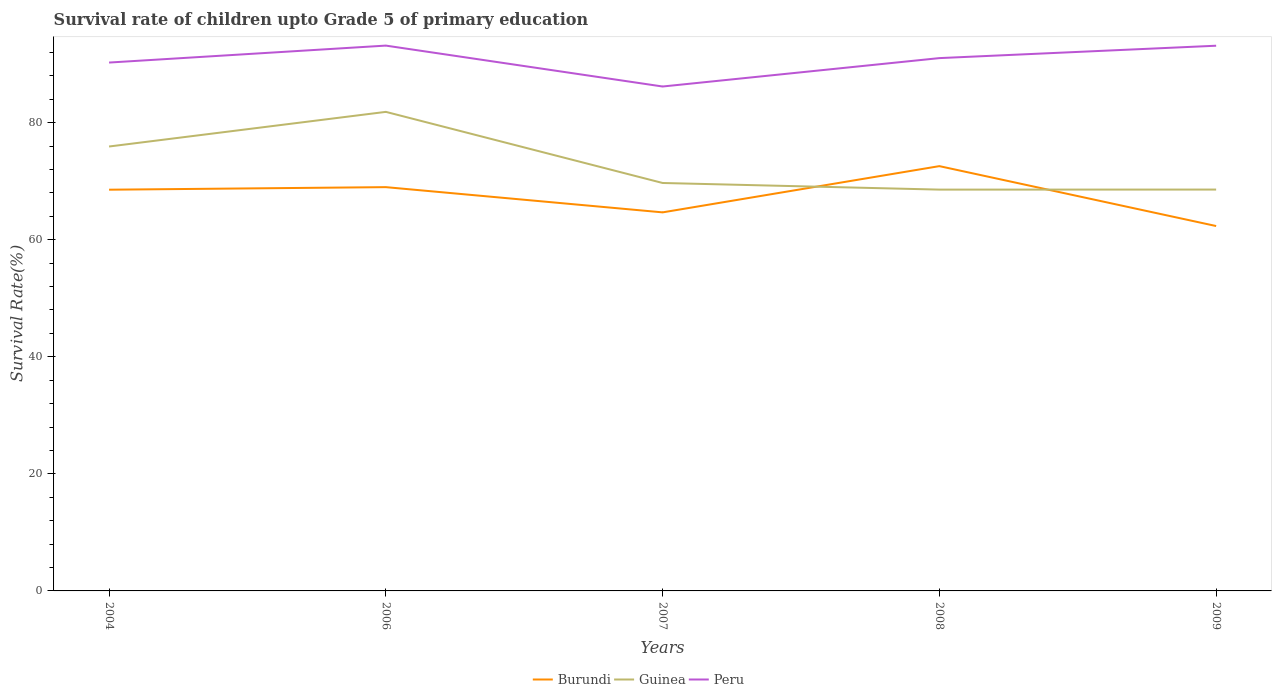Does the line corresponding to Peru intersect with the line corresponding to Burundi?
Your answer should be compact. No. Is the number of lines equal to the number of legend labels?
Your response must be concise. Yes. Across all years, what is the maximum survival rate of children in Guinea?
Your answer should be very brief. 68.57. What is the total survival rate of children in Peru in the graph?
Make the answer very short. -2.88. What is the difference between the highest and the second highest survival rate of children in Burundi?
Your answer should be very brief. 10.24. How many lines are there?
Give a very brief answer. 3. How many legend labels are there?
Give a very brief answer. 3. How are the legend labels stacked?
Make the answer very short. Horizontal. What is the title of the graph?
Provide a short and direct response. Survival rate of children upto Grade 5 of primary education. What is the label or title of the X-axis?
Make the answer very short. Years. What is the label or title of the Y-axis?
Your answer should be compact. Survival Rate(%). What is the Survival Rate(%) in Burundi in 2004?
Keep it short and to the point. 68.55. What is the Survival Rate(%) of Guinea in 2004?
Ensure brevity in your answer.  75.93. What is the Survival Rate(%) of Peru in 2004?
Your response must be concise. 90.28. What is the Survival Rate(%) of Burundi in 2006?
Provide a short and direct response. 68.99. What is the Survival Rate(%) in Guinea in 2006?
Provide a succinct answer. 81.85. What is the Survival Rate(%) in Peru in 2006?
Make the answer very short. 93.18. What is the Survival Rate(%) of Burundi in 2007?
Provide a short and direct response. 64.68. What is the Survival Rate(%) in Guinea in 2007?
Your answer should be compact. 69.7. What is the Survival Rate(%) in Peru in 2007?
Offer a very short reply. 86.19. What is the Survival Rate(%) of Burundi in 2008?
Your response must be concise. 72.58. What is the Survival Rate(%) of Guinea in 2008?
Give a very brief answer. 68.57. What is the Survival Rate(%) of Peru in 2008?
Keep it short and to the point. 91.04. What is the Survival Rate(%) of Burundi in 2009?
Your response must be concise. 62.35. What is the Survival Rate(%) of Guinea in 2009?
Provide a succinct answer. 68.58. What is the Survival Rate(%) in Peru in 2009?
Your response must be concise. 93.16. Across all years, what is the maximum Survival Rate(%) in Burundi?
Provide a succinct answer. 72.58. Across all years, what is the maximum Survival Rate(%) in Guinea?
Make the answer very short. 81.85. Across all years, what is the maximum Survival Rate(%) of Peru?
Ensure brevity in your answer.  93.18. Across all years, what is the minimum Survival Rate(%) in Burundi?
Make the answer very short. 62.35. Across all years, what is the minimum Survival Rate(%) of Guinea?
Your answer should be very brief. 68.57. Across all years, what is the minimum Survival Rate(%) of Peru?
Provide a succinct answer. 86.19. What is the total Survival Rate(%) of Burundi in the graph?
Provide a succinct answer. 337.16. What is the total Survival Rate(%) in Guinea in the graph?
Keep it short and to the point. 364.64. What is the total Survival Rate(%) of Peru in the graph?
Provide a succinct answer. 453.84. What is the difference between the Survival Rate(%) in Burundi in 2004 and that in 2006?
Make the answer very short. -0.44. What is the difference between the Survival Rate(%) in Guinea in 2004 and that in 2006?
Offer a very short reply. -5.92. What is the difference between the Survival Rate(%) of Peru in 2004 and that in 2006?
Ensure brevity in your answer.  -2.9. What is the difference between the Survival Rate(%) of Burundi in 2004 and that in 2007?
Your answer should be very brief. 3.87. What is the difference between the Survival Rate(%) in Guinea in 2004 and that in 2007?
Provide a short and direct response. 6.23. What is the difference between the Survival Rate(%) in Peru in 2004 and that in 2007?
Offer a terse response. 4.09. What is the difference between the Survival Rate(%) of Burundi in 2004 and that in 2008?
Provide a succinct answer. -4.03. What is the difference between the Survival Rate(%) of Guinea in 2004 and that in 2008?
Provide a short and direct response. 7.36. What is the difference between the Survival Rate(%) in Peru in 2004 and that in 2008?
Your answer should be compact. -0.76. What is the difference between the Survival Rate(%) of Burundi in 2004 and that in 2009?
Your response must be concise. 6.21. What is the difference between the Survival Rate(%) in Guinea in 2004 and that in 2009?
Keep it short and to the point. 7.36. What is the difference between the Survival Rate(%) in Peru in 2004 and that in 2009?
Provide a short and direct response. -2.88. What is the difference between the Survival Rate(%) of Burundi in 2006 and that in 2007?
Provide a short and direct response. 4.31. What is the difference between the Survival Rate(%) in Guinea in 2006 and that in 2007?
Your answer should be very brief. 12.15. What is the difference between the Survival Rate(%) of Peru in 2006 and that in 2007?
Give a very brief answer. 6.99. What is the difference between the Survival Rate(%) of Burundi in 2006 and that in 2008?
Provide a short and direct response. -3.59. What is the difference between the Survival Rate(%) in Guinea in 2006 and that in 2008?
Provide a succinct answer. 13.28. What is the difference between the Survival Rate(%) in Peru in 2006 and that in 2008?
Your answer should be very brief. 2.14. What is the difference between the Survival Rate(%) of Burundi in 2006 and that in 2009?
Provide a succinct answer. 6.65. What is the difference between the Survival Rate(%) of Guinea in 2006 and that in 2009?
Give a very brief answer. 13.28. What is the difference between the Survival Rate(%) of Peru in 2006 and that in 2009?
Offer a very short reply. 0.02. What is the difference between the Survival Rate(%) in Burundi in 2007 and that in 2008?
Offer a very short reply. -7.9. What is the difference between the Survival Rate(%) in Guinea in 2007 and that in 2008?
Offer a very short reply. 1.13. What is the difference between the Survival Rate(%) of Peru in 2007 and that in 2008?
Provide a succinct answer. -4.85. What is the difference between the Survival Rate(%) in Burundi in 2007 and that in 2009?
Offer a very short reply. 2.34. What is the difference between the Survival Rate(%) of Guinea in 2007 and that in 2009?
Offer a very short reply. 1.12. What is the difference between the Survival Rate(%) of Peru in 2007 and that in 2009?
Offer a very short reply. -6.97. What is the difference between the Survival Rate(%) of Burundi in 2008 and that in 2009?
Offer a very short reply. 10.24. What is the difference between the Survival Rate(%) in Guinea in 2008 and that in 2009?
Your response must be concise. -0.01. What is the difference between the Survival Rate(%) in Peru in 2008 and that in 2009?
Your response must be concise. -2.12. What is the difference between the Survival Rate(%) of Burundi in 2004 and the Survival Rate(%) of Guinea in 2006?
Your answer should be compact. -13.3. What is the difference between the Survival Rate(%) of Burundi in 2004 and the Survival Rate(%) of Peru in 2006?
Ensure brevity in your answer.  -24.62. What is the difference between the Survival Rate(%) of Guinea in 2004 and the Survival Rate(%) of Peru in 2006?
Provide a succinct answer. -17.24. What is the difference between the Survival Rate(%) in Burundi in 2004 and the Survival Rate(%) in Guinea in 2007?
Your answer should be very brief. -1.15. What is the difference between the Survival Rate(%) of Burundi in 2004 and the Survival Rate(%) of Peru in 2007?
Provide a succinct answer. -17.63. What is the difference between the Survival Rate(%) in Guinea in 2004 and the Survival Rate(%) in Peru in 2007?
Give a very brief answer. -10.25. What is the difference between the Survival Rate(%) in Burundi in 2004 and the Survival Rate(%) in Guinea in 2008?
Provide a succinct answer. -0.02. What is the difference between the Survival Rate(%) of Burundi in 2004 and the Survival Rate(%) of Peru in 2008?
Ensure brevity in your answer.  -22.48. What is the difference between the Survival Rate(%) in Guinea in 2004 and the Survival Rate(%) in Peru in 2008?
Your response must be concise. -15.1. What is the difference between the Survival Rate(%) of Burundi in 2004 and the Survival Rate(%) of Guinea in 2009?
Give a very brief answer. -0.03. What is the difference between the Survival Rate(%) in Burundi in 2004 and the Survival Rate(%) in Peru in 2009?
Make the answer very short. -24.6. What is the difference between the Survival Rate(%) of Guinea in 2004 and the Survival Rate(%) of Peru in 2009?
Offer a terse response. -17.22. What is the difference between the Survival Rate(%) of Burundi in 2006 and the Survival Rate(%) of Guinea in 2007?
Your answer should be very brief. -0.71. What is the difference between the Survival Rate(%) in Burundi in 2006 and the Survival Rate(%) in Peru in 2007?
Ensure brevity in your answer.  -17.19. What is the difference between the Survival Rate(%) of Guinea in 2006 and the Survival Rate(%) of Peru in 2007?
Provide a short and direct response. -4.33. What is the difference between the Survival Rate(%) of Burundi in 2006 and the Survival Rate(%) of Guinea in 2008?
Offer a terse response. 0.42. What is the difference between the Survival Rate(%) of Burundi in 2006 and the Survival Rate(%) of Peru in 2008?
Your answer should be compact. -22.05. What is the difference between the Survival Rate(%) of Guinea in 2006 and the Survival Rate(%) of Peru in 2008?
Provide a succinct answer. -9.18. What is the difference between the Survival Rate(%) of Burundi in 2006 and the Survival Rate(%) of Guinea in 2009?
Make the answer very short. 0.41. What is the difference between the Survival Rate(%) in Burundi in 2006 and the Survival Rate(%) in Peru in 2009?
Give a very brief answer. -24.16. What is the difference between the Survival Rate(%) of Guinea in 2006 and the Survival Rate(%) of Peru in 2009?
Provide a succinct answer. -11.3. What is the difference between the Survival Rate(%) in Burundi in 2007 and the Survival Rate(%) in Guinea in 2008?
Your answer should be very brief. -3.89. What is the difference between the Survival Rate(%) in Burundi in 2007 and the Survival Rate(%) in Peru in 2008?
Your answer should be very brief. -26.36. What is the difference between the Survival Rate(%) in Guinea in 2007 and the Survival Rate(%) in Peru in 2008?
Provide a short and direct response. -21.34. What is the difference between the Survival Rate(%) in Burundi in 2007 and the Survival Rate(%) in Guinea in 2009?
Your answer should be very brief. -3.9. What is the difference between the Survival Rate(%) in Burundi in 2007 and the Survival Rate(%) in Peru in 2009?
Provide a short and direct response. -28.47. What is the difference between the Survival Rate(%) in Guinea in 2007 and the Survival Rate(%) in Peru in 2009?
Your answer should be compact. -23.45. What is the difference between the Survival Rate(%) in Burundi in 2008 and the Survival Rate(%) in Guinea in 2009?
Your answer should be compact. 4. What is the difference between the Survival Rate(%) of Burundi in 2008 and the Survival Rate(%) of Peru in 2009?
Your answer should be very brief. -20.57. What is the difference between the Survival Rate(%) of Guinea in 2008 and the Survival Rate(%) of Peru in 2009?
Make the answer very short. -24.58. What is the average Survival Rate(%) of Burundi per year?
Offer a terse response. 67.43. What is the average Survival Rate(%) of Guinea per year?
Offer a terse response. 72.93. What is the average Survival Rate(%) in Peru per year?
Make the answer very short. 90.77. In the year 2004, what is the difference between the Survival Rate(%) in Burundi and Survival Rate(%) in Guinea?
Your answer should be compact. -7.38. In the year 2004, what is the difference between the Survival Rate(%) in Burundi and Survival Rate(%) in Peru?
Offer a terse response. -21.73. In the year 2004, what is the difference between the Survival Rate(%) of Guinea and Survival Rate(%) of Peru?
Your response must be concise. -14.34. In the year 2006, what is the difference between the Survival Rate(%) in Burundi and Survival Rate(%) in Guinea?
Your answer should be very brief. -12.86. In the year 2006, what is the difference between the Survival Rate(%) in Burundi and Survival Rate(%) in Peru?
Keep it short and to the point. -24.18. In the year 2006, what is the difference between the Survival Rate(%) of Guinea and Survival Rate(%) of Peru?
Ensure brevity in your answer.  -11.32. In the year 2007, what is the difference between the Survival Rate(%) of Burundi and Survival Rate(%) of Guinea?
Offer a terse response. -5.02. In the year 2007, what is the difference between the Survival Rate(%) in Burundi and Survival Rate(%) in Peru?
Provide a short and direct response. -21.5. In the year 2007, what is the difference between the Survival Rate(%) in Guinea and Survival Rate(%) in Peru?
Ensure brevity in your answer.  -16.48. In the year 2008, what is the difference between the Survival Rate(%) in Burundi and Survival Rate(%) in Guinea?
Your answer should be compact. 4.01. In the year 2008, what is the difference between the Survival Rate(%) of Burundi and Survival Rate(%) of Peru?
Your answer should be compact. -18.46. In the year 2008, what is the difference between the Survival Rate(%) of Guinea and Survival Rate(%) of Peru?
Keep it short and to the point. -22.47. In the year 2009, what is the difference between the Survival Rate(%) in Burundi and Survival Rate(%) in Guinea?
Give a very brief answer. -6.23. In the year 2009, what is the difference between the Survival Rate(%) in Burundi and Survival Rate(%) in Peru?
Provide a short and direct response. -30.81. In the year 2009, what is the difference between the Survival Rate(%) in Guinea and Survival Rate(%) in Peru?
Keep it short and to the point. -24.58. What is the ratio of the Survival Rate(%) in Burundi in 2004 to that in 2006?
Your response must be concise. 0.99. What is the ratio of the Survival Rate(%) in Guinea in 2004 to that in 2006?
Offer a very short reply. 0.93. What is the ratio of the Survival Rate(%) of Peru in 2004 to that in 2006?
Offer a terse response. 0.97. What is the ratio of the Survival Rate(%) of Burundi in 2004 to that in 2007?
Keep it short and to the point. 1.06. What is the ratio of the Survival Rate(%) in Guinea in 2004 to that in 2007?
Give a very brief answer. 1.09. What is the ratio of the Survival Rate(%) in Peru in 2004 to that in 2007?
Offer a terse response. 1.05. What is the ratio of the Survival Rate(%) of Burundi in 2004 to that in 2008?
Provide a succinct answer. 0.94. What is the ratio of the Survival Rate(%) in Guinea in 2004 to that in 2008?
Provide a short and direct response. 1.11. What is the ratio of the Survival Rate(%) in Peru in 2004 to that in 2008?
Provide a succinct answer. 0.99. What is the ratio of the Survival Rate(%) in Burundi in 2004 to that in 2009?
Your response must be concise. 1.1. What is the ratio of the Survival Rate(%) in Guinea in 2004 to that in 2009?
Your answer should be very brief. 1.11. What is the ratio of the Survival Rate(%) of Peru in 2004 to that in 2009?
Your answer should be compact. 0.97. What is the ratio of the Survival Rate(%) of Burundi in 2006 to that in 2007?
Your answer should be compact. 1.07. What is the ratio of the Survival Rate(%) in Guinea in 2006 to that in 2007?
Make the answer very short. 1.17. What is the ratio of the Survival Rate(%) in Peru in 2006 to that in 2007?
Provide a short and direct response. 1.08. What is the ratio of the Survival Rate(%) of Burundi in 2006 to that in 2008?
Keep it short and to the point. 0.95. What is the ratio of the Survival Rate(%) in Guinea in 2006 to that in 2008?
Your answer should be compact. 1.19. What is the ratio of the Survival Rate(%) in Peru in 2006 to that in 2008?
Provide a succinct answer. 1.02. What is the ratio of the Survival Rate(%) in Burundi in 2006 to that in 2009?
Your answer should be compact. 1.11. What is the ratio of the Survival Rate(%) of Guinea in 2006 to that in 2009?
Your answer should be compact. 1.19. What is the ratio of the Survival Rate(%) in Peru in 2006 to that in 2009?
Your answer should be very brief. 1. What is the ratio of the Survival Rate(%) of Burundi in 2007 to that in 2008?
Keep it short and to the point. 0.89. What is the ratio of the Survival Rate(%) in Guinea in 2007 to that in 2008?
Your answer should be very brief. 1.02. What is the ratio of the Survival Rate(%) of Peru in 2007 to that in 2008?
Your answer should be very brief. 0.95. What is the ratio of the Survival Rate(%) in Burundi in 2007 to that in 2009?
Offer a terse response. 1.04. What is the ratio of the Survival Rate(%) of Guinea in 2007 to that in 2009?
Your response must be concise. 1.02. What is the ratio of the Survival Rate(%) of Peru in 2007 to that in 2009?
Provide a succinct answer. 0.93. What is the ratio of the Survival Rate(%) in Burundi in 2008 to that in 2009?
Your response must be concise. 1.16. What is the ratio of the Survival Rate(%) in Guinea in 2008 to that in 2009?
Give a very brief answer. 1. What is the ratio of the Survival Rate(%) in Peru in 2008 to that in 2009?
Your response must be concise. 0.98. What is the difference between the highest and the second highest Survival Rate(%) in Burundi?
Your response must be concise. 3.59. What is the difference between the highest and the second highest Survival Rate(%) in Guinea?
Give a very brief answer. 5.92. What is the difference between the highest and the second highest Survival Rate(%) of Peru?
Provide a short and direct response. 0.02. What is the difference between the highest and the lowest Survival Rate(%) in Burundi?
Make the answer very short. 10.24. What is the difference between the highest and the lowest Survival Rate(%) in Guinea?
Offer a terse response. 13.28. What is the difference between the highest and the lowest Survival Rate(%) in Peru?
Make the answer very short. 6.99. 